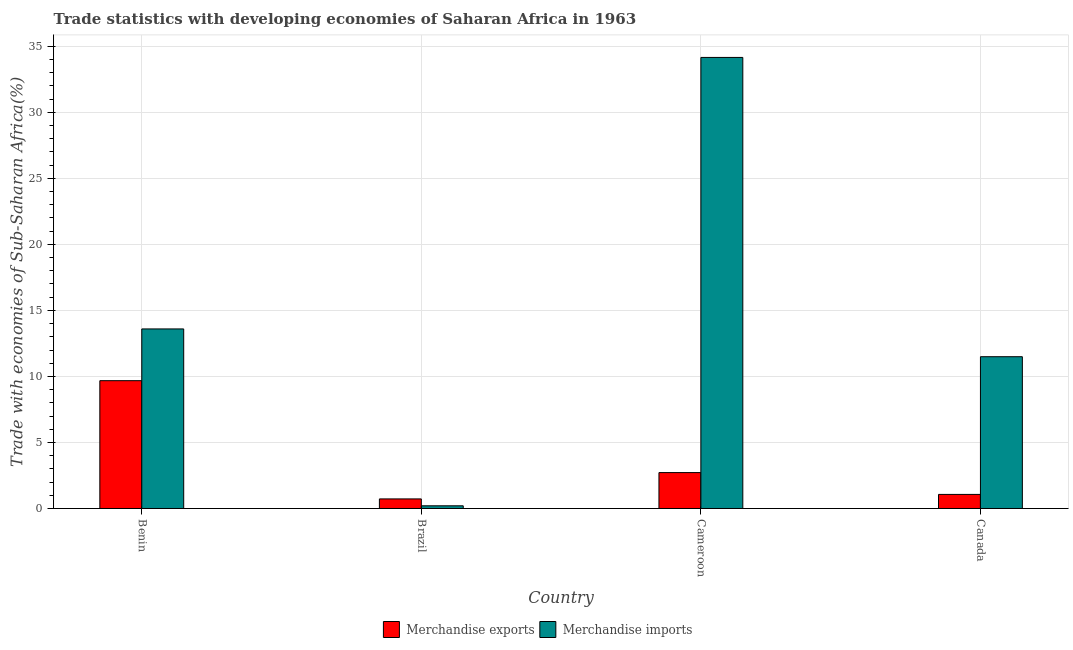How many different coloured bars are there?
Your response must be concise. 2. How many groups of bars are there?
Your response must be concise. 4. How many bars are there on the 1st tick from the right?
Ensure brevity in your answer.  2. What is the label of the 3rd group of bars from the left?
Offer a terse response. Cameroon. What is the merchandise exports in Canada?
Make the answer very short. 1.07. Across all countries, what is the maximum merchandise exports?
Your response must be concise. 9.68. Across all countries, what is the minimum merchandise exports?
Your answer should be compact. 0.72. In which country was the merchandise imports maximum?
Provide a short and direct response. Cameroon. What is the total merchandise imports in the graph?
Make the answer very short. 59.44. What is the difference between the merchandise imports in Benin and that in Cameroon?
Offer a terse response. -20.56. What is the difference between the merchandise exports in Brazil and the merchandise imports in Benin?
Make the answer very short. -12.87. What is the average merchandise imports per country?
Keep it short and to the point. 14.86. What is the difference between the merchandise imports and merchandise exports in Canada?
Your answer should be very brief. 10.43. What is the ratio of the merchandise exports in Benin to that in Cameroon?
Provide a succinct answer. 3.56. Is the merchandise exports in Benin less than that in Cameroon?
Ensure brevity in your answer.  No. What is the difference between the highest and the second highest merchandise exports?
Make the answer very short. 6.96. What is the difference between the highest and the lowest merchandise imports?
Make the answer very short. 33.95. In how many countries, is the merchandise imports greater than the average merchandise imports taken over all countries?
Make the answer very short. 1. Are all the bars in the graph horizontal?
Keep it short and to the point. No. How many countries are there in the graph?
Offer a very short reply. 4. What is the difference between two consecutive major ticks on the Y-axis?
Keep it short and to the point. 5. Are the values on the major ticks of Y-axis written in scientific E-notation?
Give a very brief answer. No. What is the title of the graph?
Your response must be concise. Trade statistics with developing economies of Saharan Africa in 1963. What is the label or title of the Y-axis?
Offer a terse response. Trade with economies of Sub-Saharan Africa(%). What is the Trade with economies of Sub-Saharan Africa(%) in Merchandise exports in Benin?
Provide a short and direct response. 9.68. What is the Trade with economies of Sub-Saharan Africa(%) of Merchandise imports in Benin?
Give a very brief answer. 13.6. What is the Trade with economies of Sub-Saharan Africa(%) in Merchandise exports in Brazil?
Your answer should be very brief. 0.72. What is the Trade with economies of Sub-Saharan Africa(%) of Merchandise imports in Brazil?
Ensure brevity in your answer.  0.2. What is the Trade with economies of Sub-Saharan Africa(%) of Merchandise exports in Cameroon?
Provide a short and direct response. 2.72. What is the Trade with economies of Sub-Saharan Africa(%) in Merchandise imports in Cameroon?
Ensure brevity in your answer.  34.15. What is the Trade with economies of Sub-Saharan Africa(%) in Merchandise exports in Canada?
Offer a very short reply. 1.07. What is the Trade with economies of Sub-Saharan Africa(%) of Merchandise imports in Canada?
Provide a succinct answer. 11.49. Across all countries, what is the maximum Trade with economies of Sub-Saharan Africa(%) of Merchandise exports?
Your response must be concise. 9.68. Across all countries, what is the maximum Trade with economies of Sub-Saharan Africa(%) of Merchandise imports?
Give a very brief answer. 34.15. Across all countries, what is the minimum Trade with economies of Sub-Saharan Africa(%) in Merchandise exports?
Ensure brevity in your answer.  0.72. Across all countries, what is the minimum Trade with economies of Sub-Saharan Africa(%) in Merchandise imports?
Make the answer very short. 0.2. What is the total Trade with economies of Sub-Saharan Africa(%) of Merchandise exports in the graph?
Provide a short and direct response. 14.19. What is the total Trade with economies of Sub-Saharan Africa(%) in Merchandise imports in the graph?
Your answer should be very brief. 59.44. What is the difference between the Trade with economies of Sub-Saharan Africa(%) of Merchandise exports in Benin and that in Brazil?
Provide a succinct answer. 8.95. What is the difference between the Trade with economies of Sub-Saharan Africa(%) of Merchandise imports in Benin and that in Brazil?
Make the answer very short. 13.39. What is the difference between the Trade with economies of Sub-Saharan Africa(%) of Merchandise exports in Benin and that in Cameroon?
Your response must be concise. 6.96. What is the difference between the Trade with economies of Sub-Saharan Africa(%) of Merchandise imports in Benin and that in Cameroon?
Your response must be concise. -20.56. What is the difference between the Trade with economies of Sub-Saharan Africa(%) in Merchandise exports in Benin and that in Canada?
Make the answer very short. 8.61. What is the difference between the Trade with economies of Sub-Saharan Africa(%) in Merchandise imports in Benin and that in Canada?
Make the answer very short. 2.1. What is the difference between the Trade with economies of Sub-Saharan Africa(%) in Merchandise exports in Brazil and that in Cameroon?
Provide a short and direct response. -1.99. What is the difference between the Trade with economies of Sub-Saharan Africa(%) in Merchandise imports in Brazil and that in Cameroon?
Keep it short and to the point. -33.95. What is the difference between the Trade with economies of Sub-Saharan Africa(%) of Merchandise exports in Brazil and that in Canada?
Give a very brief answer. -0.34. What is the difference between the Trade with economies of Sub-Saharan Africa(%) in Merchandise imports in Brazil and that in Canada?
Make the answer very short. -11.29. What is the difference between the Trade with economies of Sub-Saharan Africa(%) in Merchandise exports in Cameroon and that in Canada?
Provide a succinct answer. 1.65. What is the difference between the Trade with economies of Sub-Saharan Africa(%) in Merchandise imports in Cameroon and that in Canada?
Your answer should be very brief. 22.66. What is the difference between the Trade with economies of Sub-Saharan Africa(%) in Merchandise exports in Benin and the Trade with economies of Sub-Saharan Africa(%) in Merchandise imports in Brazil?
Offer a very short reply. 9.47. What is the difference between the Trade with economies of Sub-Saharan Africa(%) of Merchandise exports in Benin and the Trade with economies of Sub-Saharan Africa(%) of Merchandise imports in Cameroon?
Make the answer very short. -24.48. What is the difference between the Trade with economies of Sub-Saharan Africa(%) in Merchandise exports in Benin and the Trade with economies of Sub-Saharan Africa(%) in Merchandise imports in Canada?
Give a very brief answer. -1.81. What is the difference between the Trade with economies of Sub-Saharan Africa(%) of Merchandise exports in Brazil and the Trade with economies of Sub-Saharan Africa(%) of Merchandise imports in Cameroon?
Offer a terse response. -33.43. What is the difference between the Trade with economies of Sub-Saharan Africa(%) in Merchandise exports in Brazil and the Trade with economies of Sub-Saharan Africa(%) in Merchandise imports in Canada?
Offer a very short reply. -10.77. What is the difference between the Trade with economies of Sub-Saharan Africa(%) in Merchandise exports in Cameroon and the Trade with economies of Sub-Saharan Africa(%) in Merchandise imports in Canada?
Offer a very short reply. -8.77. What is the average Trade with economies of Sub-Saharan Africa(%) of Merchandise exports per country?
Your response must be concise. 3.55. What is the average Trade with economies of Sub-Saharan Africa(%) in Merchandise imports per country?
Make the answer very short. 14.86. What is the difference between the Trade with economies of Sub-Saharan Africa(%) in Merchandise exports and Trade with economies of Sub-Saharan Africa(%) in Merchandise imports in Benin?
Offer a terse response. -3.92. What is the difference between the Trade with economies of Sub-Saharan Africa(%) of Merchandise exports and Trade with economies of Sub-Saharan Africa(%) of Merchandise imports in Brazil?
Your response must be concise. 0.52. What is the difference between the Trade with economies of Sub-Saharan Africa(%) of Merchandise exports and Trade with economies of Sub-Saharan Africa(%) of Merchandise imports in Cameroon?
Your answer should be very brief. -31.43. What is the difference between the Trade with economies of Sub-Saharan Africa(%) in Merchandise exports and Trade with economies of Sub-Saharan Africa(%) in Merchandise imports in Canada?
Ensure brevity in your answer.  -10.43. What is the ratio of the Trade with economies of Sub-Saharan Africa(%) in Merchandise exports in Benin to that in Brazil?
Offer a terse response. 13.35. What is the ratio of the Trade with economies of Sub-Saharan Africa(%) in Merchandise imports in Benin to that in Brazil?
Provide a succinct answer. 66.87. What is the ratio of the Trade with economies of Sub-Saharan Africa(%) in Merchandise exports in Benin to that in Cameroon?
Keep it short and to the point. 3.56. What is the ratio of the Trade with economies of Sub-Saharan Africa(%) in Merchandise imports in Benin to that in Cameroon?
Keep it short and to the point. 0.4. What is the ratio of the Trade with economies of Sub-Saharan Africa(%) in Merchandise exports in Benin to that in Canada?
Your answer should be very brief. 9.08. What is the ratio of the Trade with economies of Sub-Saharan Africa(%) in Merchandise imports in Benin to that in Canada?
Provide a succinct answer. 1.18. What is the ratio of the Trade with economies of Sub-Saharan Africa(%) in Merchandise exports in Brazil to that in Cameroon?
Make the answer very short. 0.27. What is the ratio of the Trade with economies of Sub-Saharan Africa(%) of Merchandise imports in Brazil to that in Cameroon?
Provide a short and direct response. 0.01. What is the ratio of the Trade with economies of Sub-Saharan Africa(%) in Merchandise exports in Brazil to that in Canada?
Your answer should be compact. 0.68. What is the ratio of the Trade with economies of Sub-Saharan Africa(%) of Merchandise imports in Brazil to that in Canada?
Give a very brief answer. 0.02. What is the ratio of the Trade with economies of Sub-Saharan Africa(%) of Merchandise exports in Cameroon to that in Canada?
Offer a terse response. 2.55. What is the ratio of the Trade with economies of Sub-Saharan Africa(%) in Merchandise imports in Cameroon to that in Canada?
Make the answer very short. 2.97. What is the difference between the highest and the second highest Trade with economies of Sub-Saharan Africa(%) in Merchandise exports?
Provide a succinct answer. 6.96. What is the difference between the highest and the second highest Trade with economies of Sub-Saharan Africa(%) in Merchandise imports?
Keep it short and to the point. 20.56. What is the difference between the highest and the lowest Trade with economies of Sub-Saharan Africa(%) in Merchandise exports?
Your answer should be compact. 8.95. What is the difference between the highest and the lowest Trade with economies of Sub-Saharan Africa(%) of Merchandise imports?
Your answer should be compact. 33.95. 